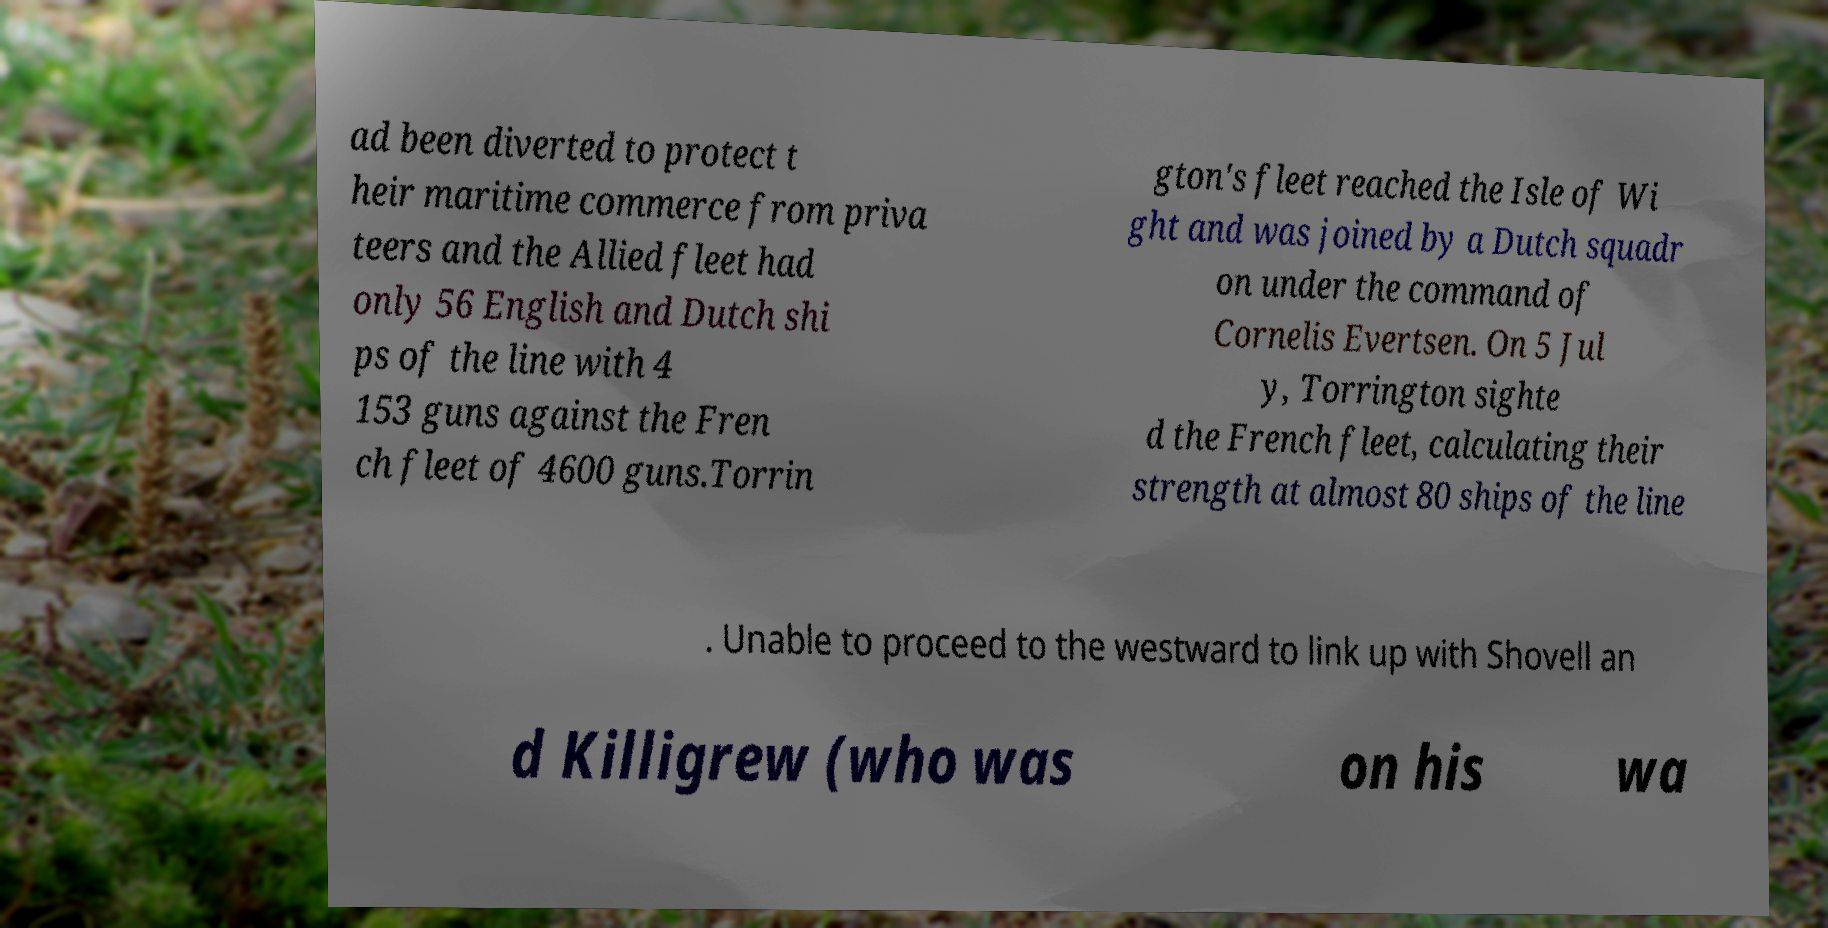Could you assist in decoding the text presented in this image and type it out clearly? ad been diverted to protect t heir maritime commerce from priva teers and the Allied fleet had only 56 English and Dutch shi ps of the line with 4 153 guns against the Fren ch fleet of 4600 guns.Torrin gton's fleet reached the Isle of Wi ght and was joined by a Dutch squadr on under the command of Cornelis Evertsen. On 5 Jul y, Torrington sighte d the French fleet, calculating their strength at almost 80 ships of the line . Unable to proceed to the westward to link up with Shovell an d Killigrew (who was on his wa 